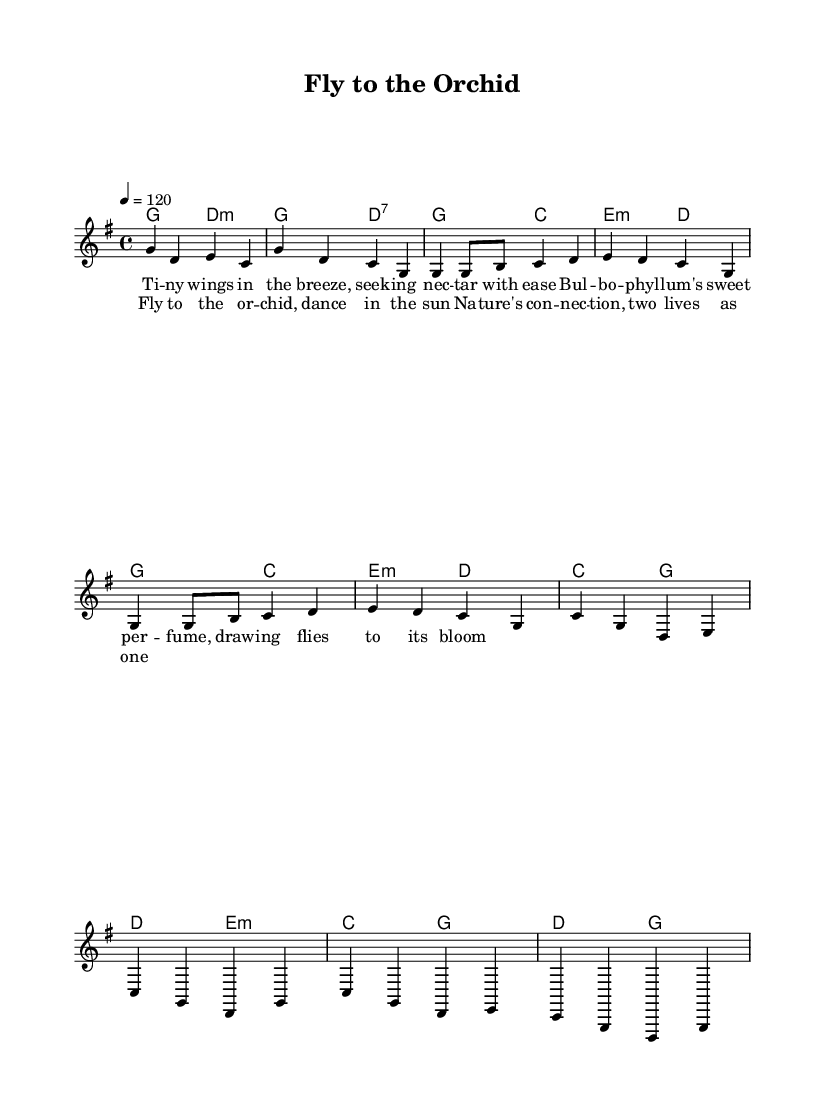What is the key signature of this music? The key signature is G major, which has one sharp (F#). You can identify the key signature based on the symbol at the beginning of the staff where the notes are written.
Answer: G major What is the time signature of this piece? The time signature displayed at the beginning of the piece is 4/4, which indicates four beats in each measure and a quarter note receives one beat. This is seen right after the key signature.
Answer: 4/4 What is the tempo marking for this piece? The tempo marking indicated in the music is 120 beats per minute, which is noted at the beginning of the score. This tells the performer how fast to play the piece.
Answer: 120 How many measures are in the chorus section? The chorus section consists of four measures, as seen in the layout of the music where the corresponding notes and chords are grouped within that section.
Answer: 4 What is the first note of the melody in the verse? The first note of the melody in the verse is G, which can be identified from the beginning of the melody line indicated in the staff.
Answer: G What is the relationship discussed in the lyrics? The lyrics describe the symbiotic relationship between the Bulbophyllum orchid and the flies that pollinate it, highlighting mutual benefits as they interact with each other. This thematic essence can be extracted from the words in the lyrics provided.
Answer: Symbiotic relationship What type of chord is played during the intro? The chords played during the intro are G major and D minor, which are identified through the chord symbols written above the melody notes in the sheet music.
Answer: G major, D minor 